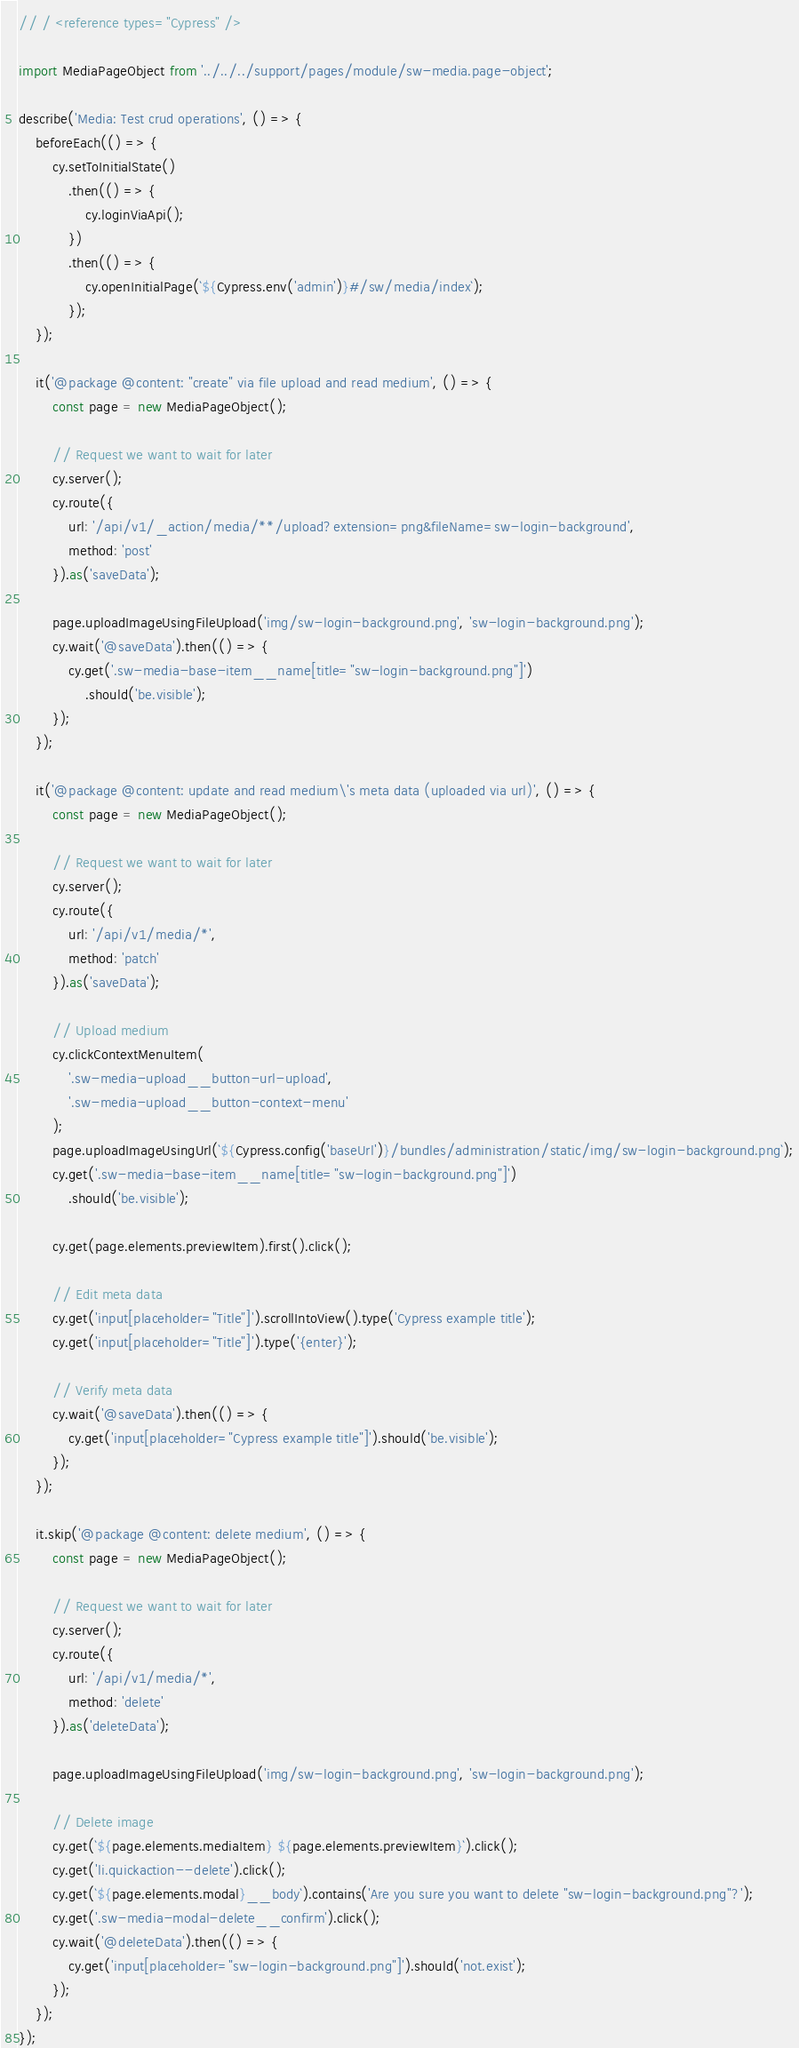<code> <loc_0><loc_0><loc_500><loc_500><_JavaScript_>// / <reference types="Cypress" />

import MediaPageObject from '../../../support/pages/module/sw-media.page-object';

describe('Media: Test crud operations', () => {
    beforeEach(() => {
        cy.setToInitialState()
            .then(() => {
                cy.loginViaApi();
            })
            .then(() => {
                cy.openInitialPage(`${Cypress.env('admin')}#/sw/media/index`);
            });
    });

    it('@package @content: "create" via file upload and read medium', () => {
        const page = new MediaPageObject();

        // Request we want to wait for later
        cy.server();
        cy.route({
            url: '/api/v1/_action/media/**/upload?extension=png&fileName=sw-login-background',
            method: 'post'
        }).as('saveData');

        page.uploadImageUsingFileUpload('img/sw-login-background.png', 'sw-login-background.png');
        cy.wait('@saveData').then(() => {
            cy.get('.sw-media-base-item__name[title="sw-login-background.png"]')
                .should('be.visible');
        });
    });

    it('@package @content: update and read medium\'s meta data (uploaded via url)', () => {
        const page = new MediaPageObject();

        // Request we want to wait for later
        cy.server();
        cy.route({
            url: '/api/v1/media/*',
            method: 'patch'
        }).as('saveData');

        // Upload medium
        cy.clickContextMenuItem(
            '.sw-media-upload__button-url-upload',
            '.sw-media-upload__button-context-menu'
        );
        page.uploadImageUsingUrl(`${Cypress.config('baseUrl')}/bundles/administration/static/img/sw-login-background.png`);
        cy.get('.sw-media-base-item__name[title="sw-login-background.png"]')
            .should('be.visible');

        cy.get(page.elements.previewItem).first().click();

        // Edit meta data
        cy.get('input[placeholder="Title"]').scrollIntoView().type('Cypress example title');
        cy.get('input[placeholder="Title"]').type('{enter}');

        // Verify meta data
        cy.wait('@saveData').then(() => {
            cy.get('input[placeholder="Cypress example title"]').should('be.visible');
        });
    });

    it.skip('@package @content: delete medium', () => {
        const page = new MediaPageObject();

        // Request we want to wait for later
        cy.server();
        cy.route({
            url: '/api/v1/media/*',
            method: 'delete'
        }).as('deleteData');

        page.uploadImageUsingFileUpload('img/sw-login-background.png', 'sw-login-background.png');

        // Delete image
        cy.get(`${page.elements.mediaItem} ${page.elements.previewItem}`).click();
        cy.get('li.quickaction--delete').click();
        cy.get(`${page.elements.modal}__body`).contains('Are you sure you want to delete "sw-login-background.png"?');
        cy.get('.sw-media-modal-delete__confirm').click();
        cy.wait('@deleteData').then(() => {
            cy.get('input[placeholder="sw-login-background.png"]').should('not.exist');
        });
    });
});
</code> 